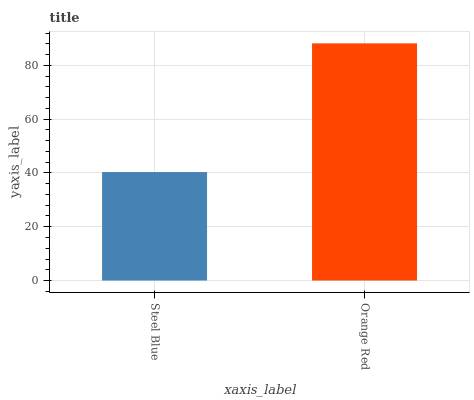Is Steel Blue the minimum?
Answer yes or no. Yes. Is Orange Red the maximum?
Answer yes or no. Yes. Is Orange Red the minimum?
Answer yes or no. No. Is Orange Red greater than Steel Blue?
Answer yes or no. Yes. Is Steel Blue less than Orange Red?
Answer yes or no. Yes. Is Steel Blue greater than Orange Red?
Answer yes or no. No. Is Orange Red less than Steel Blue?
Answer yes or no. No. Is Orange Red the high median?
Answer yes or no. Yes. Is Steel Blue the low median?
Answer yes or no. Yes. Is Steel Blue the high median?
Answer yes or no. No. Is Orange Red the low median?
Answer yes or no. No. 